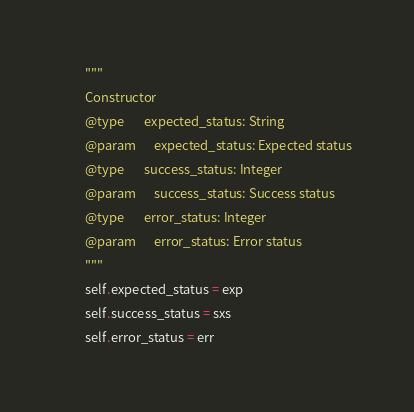Convert code to text. <code><loc_0><loc_0><loc_500><loc_500><_Python_>        """
        Constructor
        @type       expected_status: String
        @param      expected_status: Expected status
        @type       success_status: Integer
        @param      success_status: Success status
        @type       error_status: Integer
        @param      error_status: Error status
        """
        self.expected_status = exp
        self.success_status = sxs
        self.error_status = err</code> 